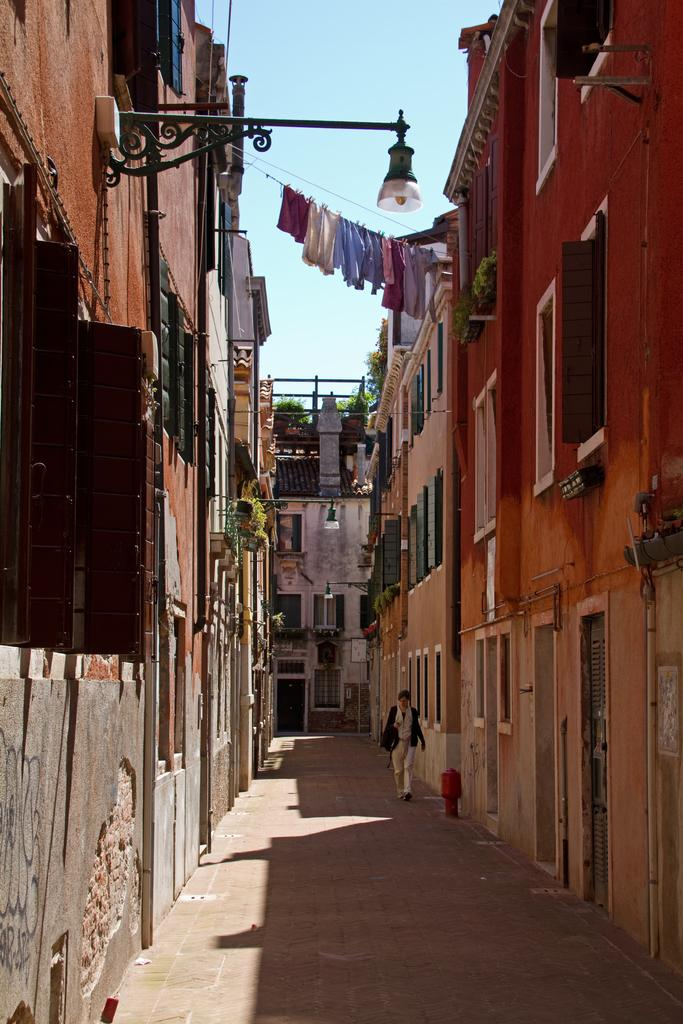What type of structures can be seen in the image? There are buildings in the image. Who is present in the image? There are women in the image. What can be seen covering the women's bodies? Clothes are visible in the image. What is providing illumination in the image? Lights are present in the image. What architectural features can be seen on the buildings? Windows are present in the image. What type of vegetation is visible in the image? Plants are visible in the image. What surface are the women standing on? There is a floor in the image. What part of the natural environment is visible in the image? The sky is visible in the image. Can you tell me how many times the kitty sneezes in the image? There is no kitty present in the image, and therefore no sneezing can be observed. What emotion do the women in the image feel when they regret their decisions? There is no indication of regret or any emotions in the image, so it cannot be determined from the picture. 